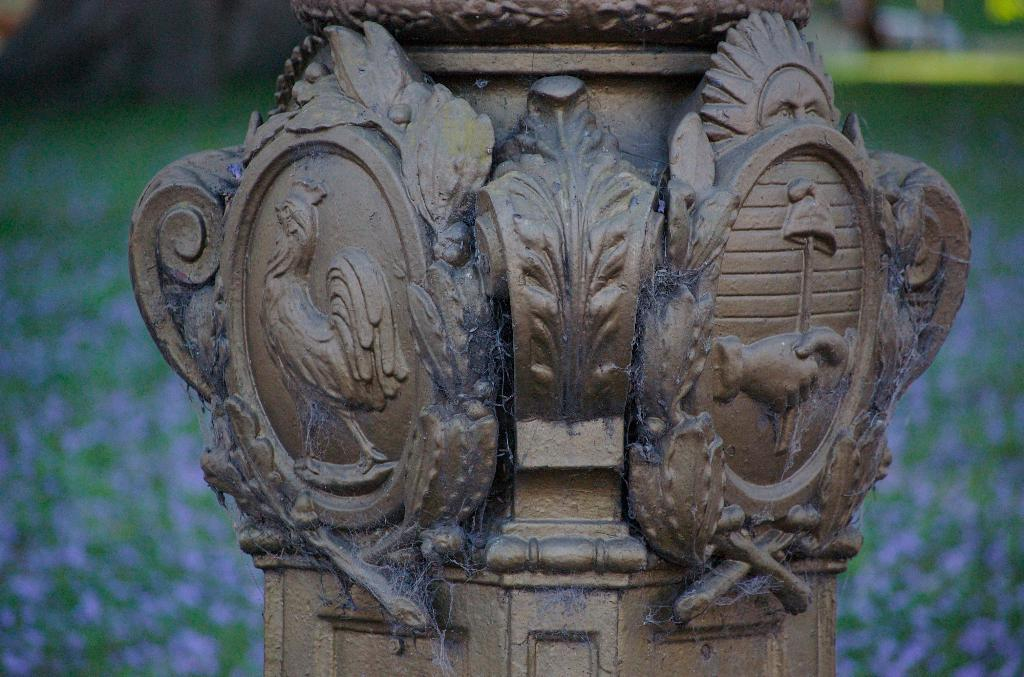What is the main subject in the foreground of the image? There is a sculpture on a pillar in the foreground of the image. Can you describe the background of the image? The background of the image is blurry. What type of cake is being offered to the beggar in the image? There is no cake or beggar present in the image; it features a sculpture on a pillar in the foreground and a blurry background. How many jellyfish can be seen swimming in the background of the image? There are no jellyfish present in the image; it features a sculpture on a pillar in the foreground and a blurry background. 